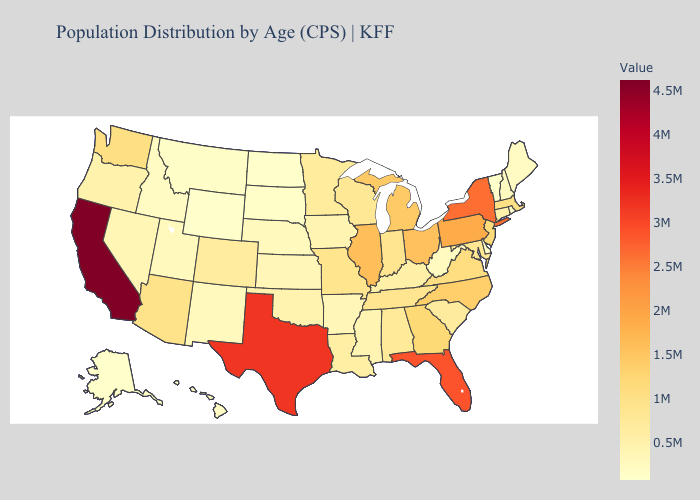Among the states that border Colorado , which have the highest value?
Quick response, please. Arizona. Does Indiana have the highest value in the USA?
Quick response, please. No. Which states hav the highest value in the West?
Keep it brief. California. Which states have the highest value in the USA?
Keep it brief. California. Does the map have missing data?
Short answer required. No. 